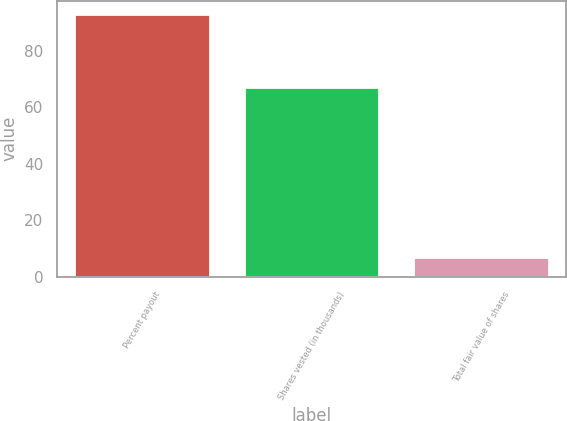Convert chart to OTSL. <chart><loc_0><loc_0><loc_500><loc_500><bar_chart><fcel>Percent payout<fcel>Shares vested (in thousands)<fcel>Total fair value of shares<nl><fcel>93<fcel>67<fcel>7.1<nl></chart> 